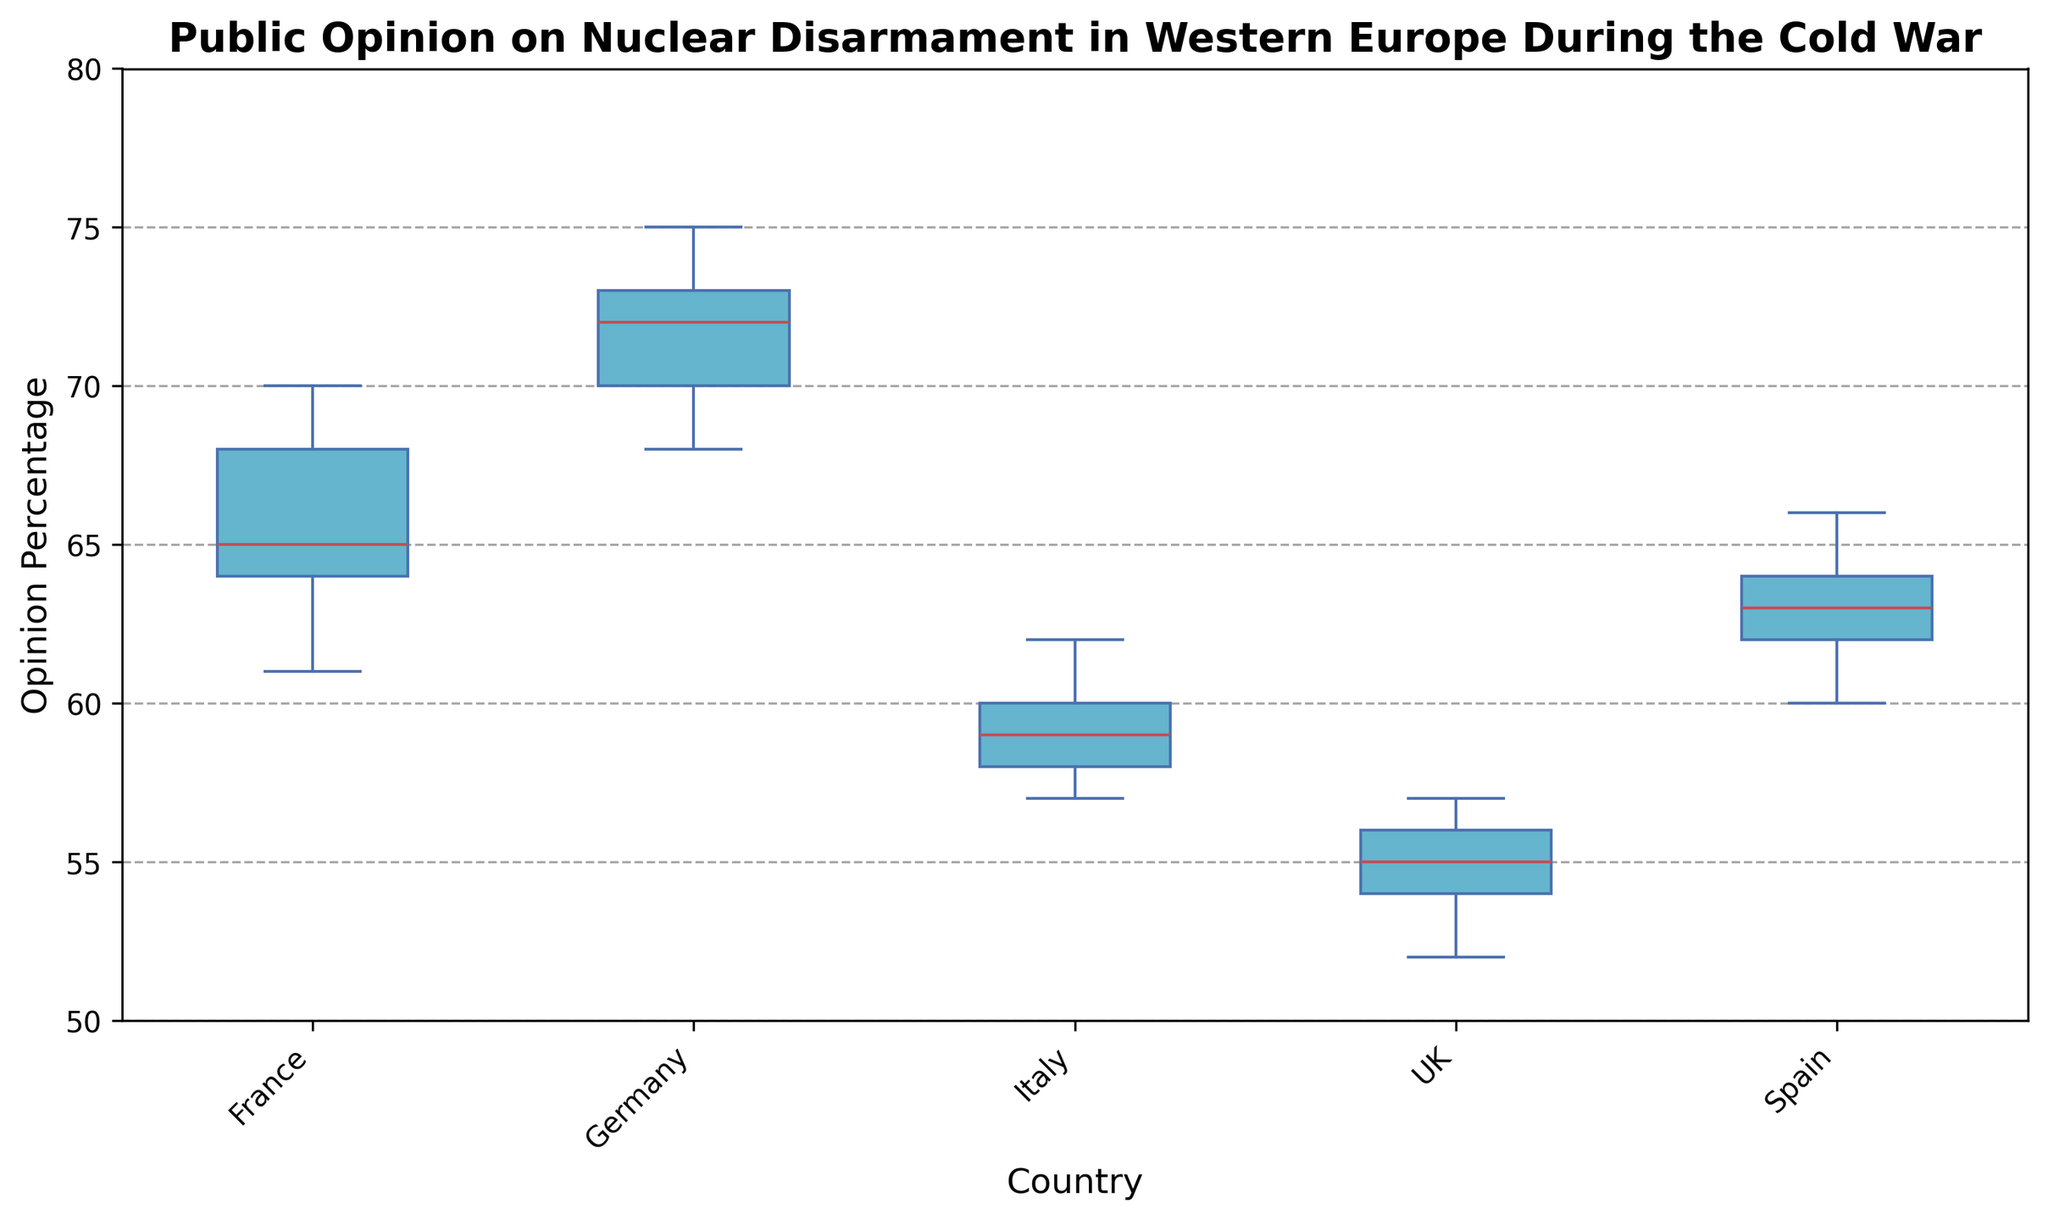Which country has the highest median opinion percentage on nuclear disarmament? To identify which country has the highest median, observe the red lines (medians) in the box plots. The median for Germany appears higher than the others.
Answer: Germany What is the interquartile range (IQR) for France's public opinion on nuclear disarmament? The IQR is calculated by subtracting the 25th percentile (bottom of the box) from the 75th percentile (top of the box) for France's box plot. The approximate values are 61 (25th percentile) and 68 (75th percentile). Thus, the IQR = 68 - 61 = 7.
Answer: 7 How does the median opinion percentage of the UK compare to that of Spain? Compare the medians (red lines) in the box plots: the UK has a median around 55, and Spain has a median around 63. So, Spain's median is higher than the UK's.
Answer: Spain's median is higher Are there any countries with outliers in their public opinion data? Outliers are represented by individual points outside the whiskers of the box plots. None of the countries have visible outliers in the rendered figure.
Answer: No Which country has the smallest range in their public opinion percentages? The range is the difference between the maximum and minimum values, represented by the ends of the whiskers. The UK has the smallest range of approximately 52 to 57.
Answer: UK What is the difference between the highest opinion percentage in Germany and the lowest opinion percentage in Italy? The highest opinion percentage in Germany is at the top whisker (~75), and the lowest in Italy is at the bottom whisker (~57). The difference is 75 - 57 = 18.
Answer: 18 Which country shows the most variability in public opinion, and how can you tell? The country with the most variability has the widest box plot and/or whiskers. France shows substantial variability with a broader box (interquartile range) and longer whiskers.
Answer: France What is the average of the medians for all countries? Identify the median (red line) for each country: France (~65), Germany (~72), Italy (~59), UK (~55), and Spain (~63). Sum these values and divide by the number of countries: (65 + 72 + 59 + 55 + 63) / 5 = 62.8.
Answer: 62.8 Between Italy and France, which country has a more spread out opinion on nuclear disarmament? Compare the lengths of the boxes and whiskers. France has a wider box and longer whiskers than Italy, indicating a more spread out opinion.
Answer: France Which country has the highest upper quartile (75th percentile) opinion percentage, and what does this indicate? The upper quartile (75th percentile) is represented by the top of the box. Germany has the highest upper quartile (~74), indicating that a significant portion of the population holds a high opinion percentage.
Answer: Germany 